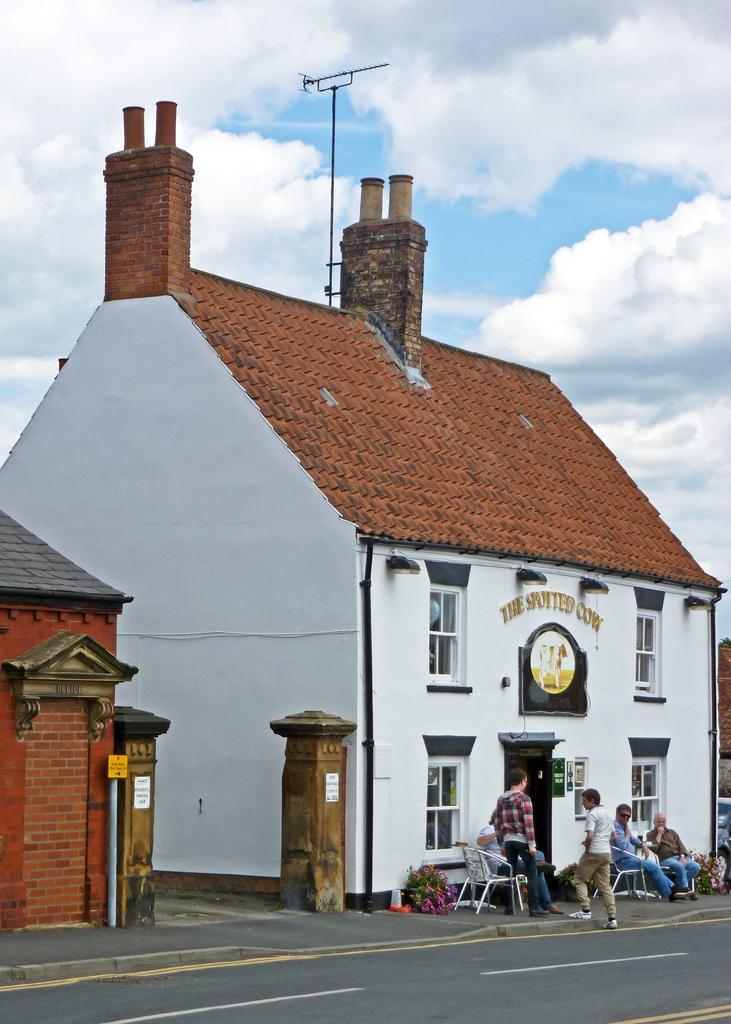How would you summarize this image in a sentence or two? In this image there is a house in middle of this image which is in white color. There are some persons at bottom right corner of this image and there is a tower at top of this house, and there is a cloudy sky at top of this image and there is a road at bottom of this image. 